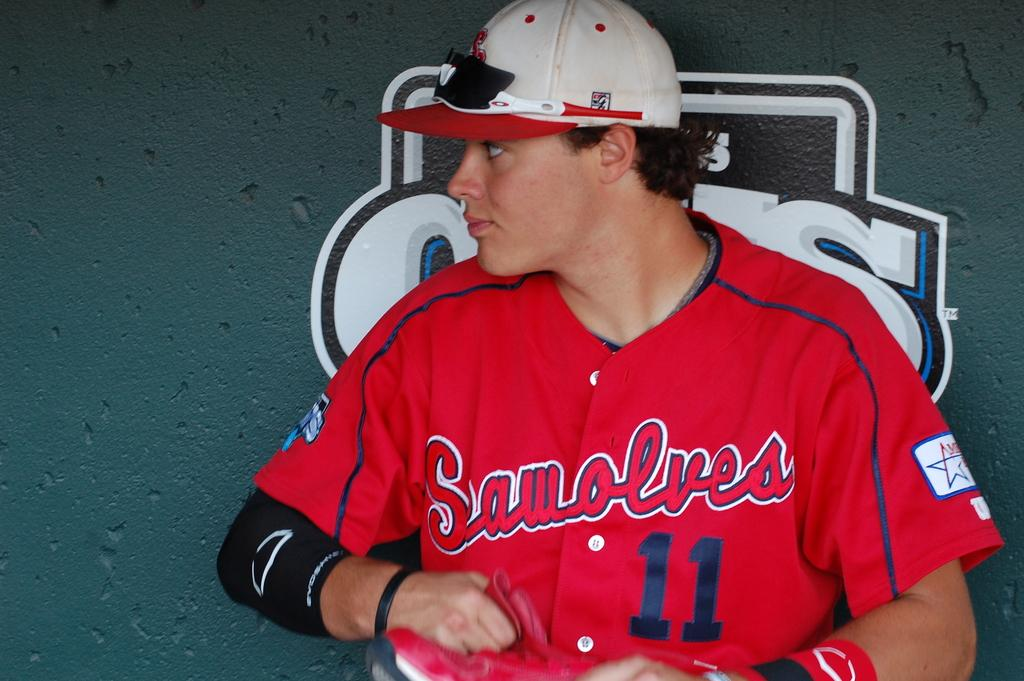<image>
Provide a brief description of the given image. Team player 11 from the Seawolves sits in the dugout looking to his right. 